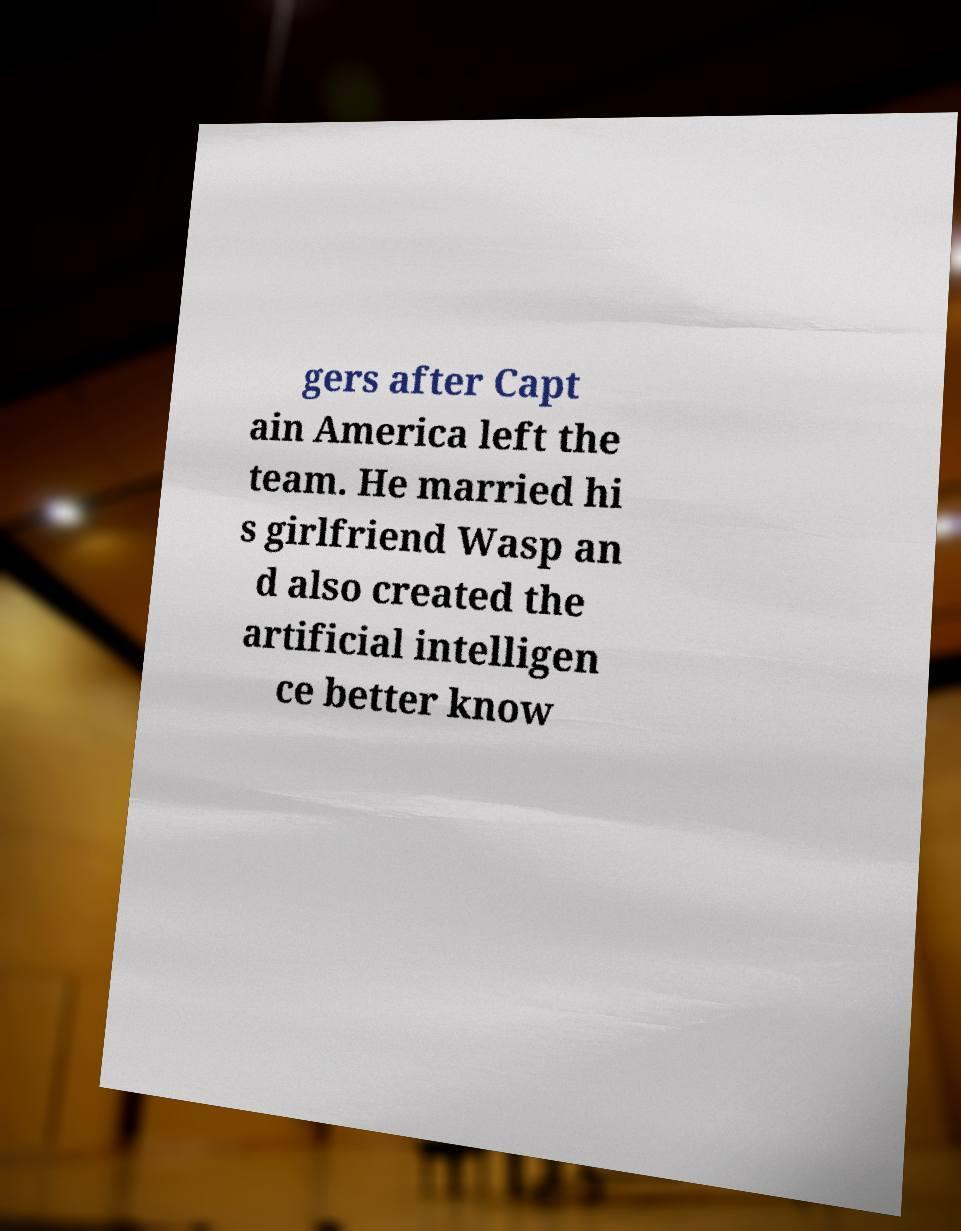Could you extract and type out the text from this image? gers after Capt ain America left the team. He married hi s girlfriend Wasp an d also created the artificial intelligen ce better know 